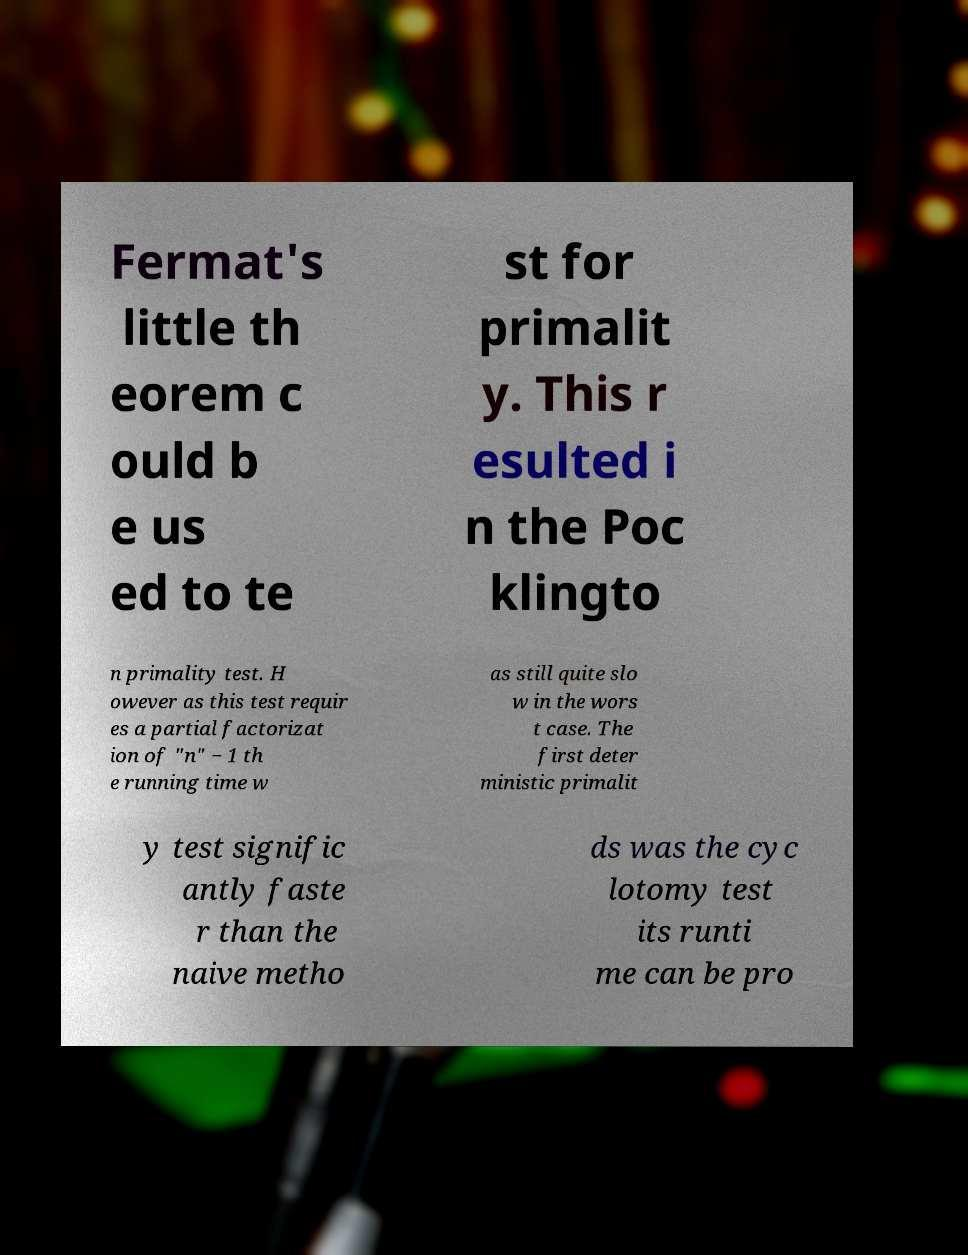Could you extract and type out the text from this image? Fermat's little th eorem c ould b e us ed to te st for primalit y. This r esulted i n the Poc klingto n primality test. H owever as this test requir es a partial factorizat ion of "n" − 1 th e running time w as still quite slo w in the wors t case. The first deter ministic primalit y test signific antly faste r than the naive metho ds was the cyc lotomy test its runti me can be pro 